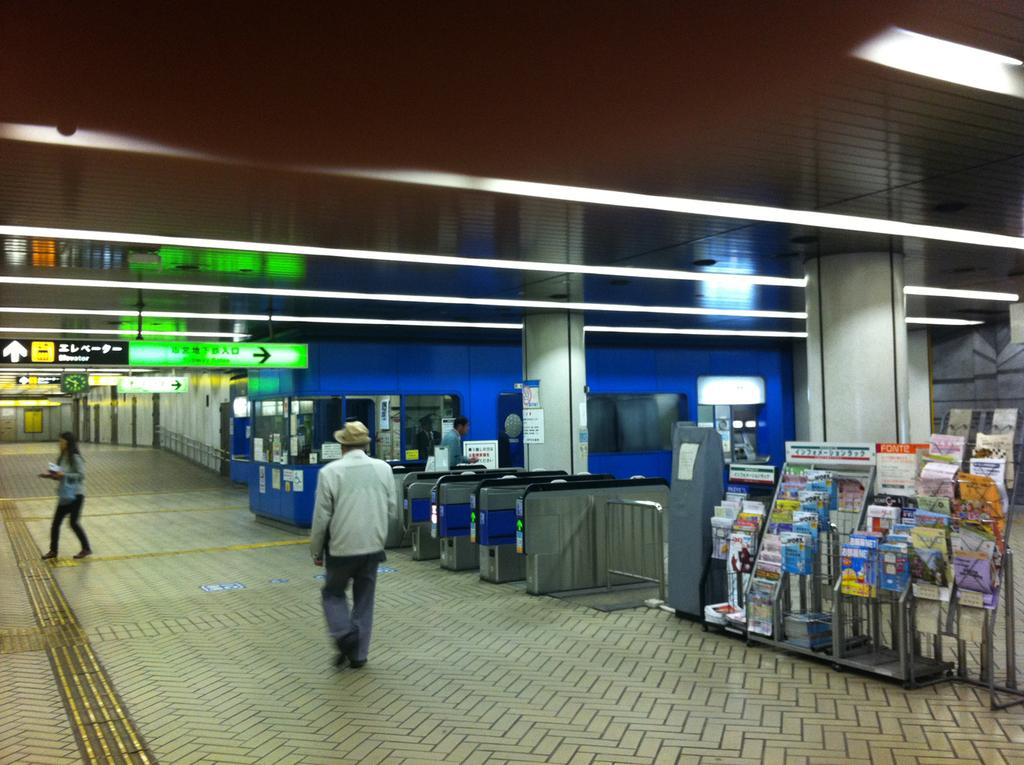What are the two people in the image doing? The two people in the image are walking. Can you describe any objects or structures in the image? Yes, there is a bookshelf in the image. What type of chair is the lawyer sitting on in the image? There is no chair or lawyer present in the image; it only features two people walking and a bookshelf. 